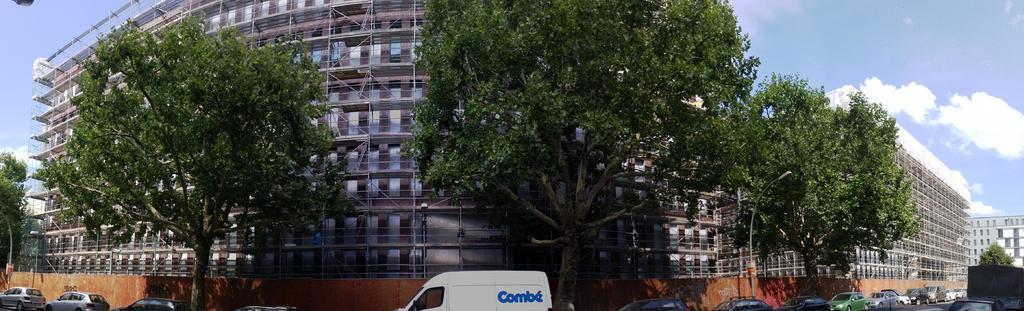How would you summarize this image in a sentence or two? In this image I can see few vehicles. In front the vehicle is in white color, background I can see trees in green color, a building in brown and gray color and the sky is in white and blue color. 